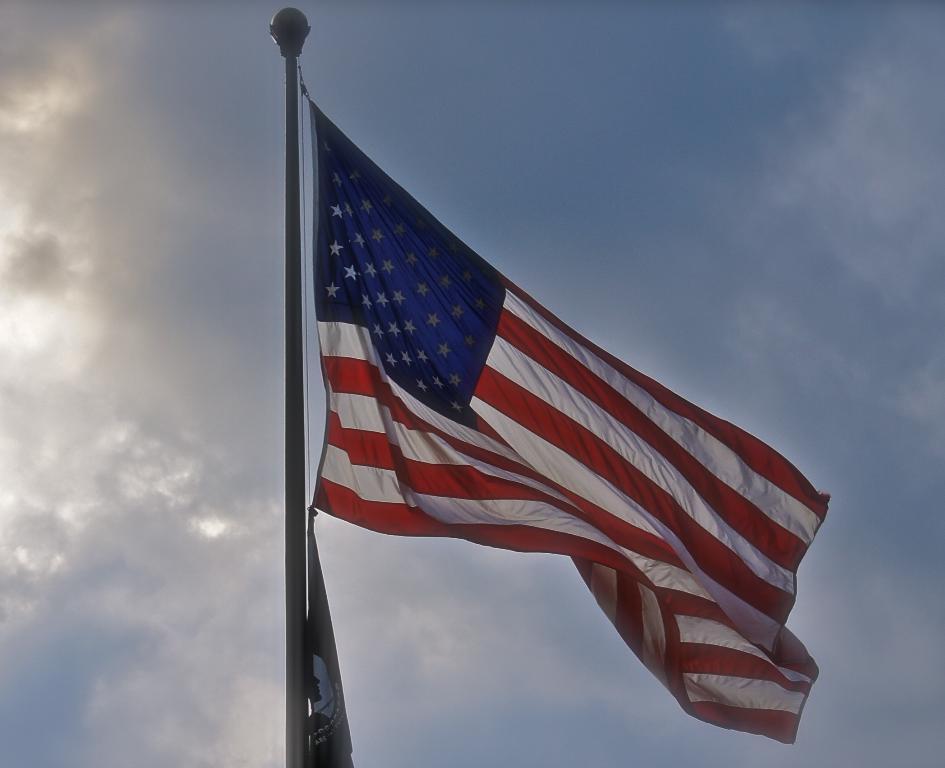Could you give a brief overview of what you see in this image? In the middle of this image, there is a flag attached to a thread which is connected to a pole. In the background, there are clouds in the blue sky. 